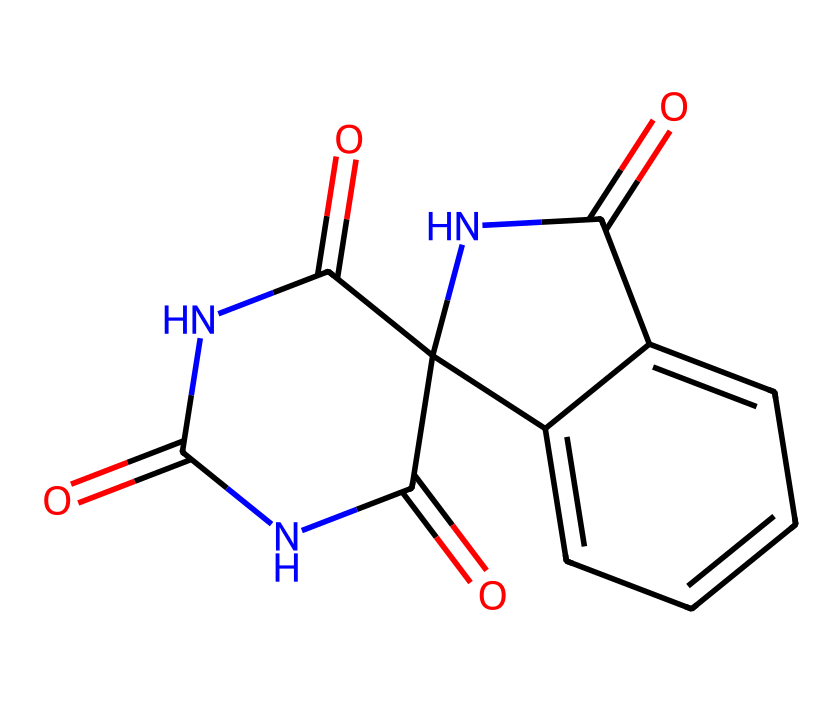How many carbon atoms are present in this compound? The SMILES representation shows a total of 15 carbon (C) atoms, identifiable from the molecular structure as indicated by the count of 'C' characters in the formula.
Answer: 15 What functional groups are present in this chemical? The structure contains amide groups (-C(=O)N-) and carbonyl groups (C=O), which are visible from the arrangement of the atoms in the SMILES representation.
Answer: amide, carbonyl How many nitrogen atoms are in the molecule? From the SMILES notation, there are 3 nitrogen (N) atoms present, identified by the occurrences of 'N' in the structure.
Answer: 3 What is the degree of saturation in this compound? The degree of saturation can be inferred by analyzing the number of double bonds and rings; the presence of both suggests a degree of saturation indicating 9.
Answer: 9 What type of reaction might this compound undergo when exposed to UV light? Given that the compound is UV-reactive due to its conjugated structure, it is likely to undergo a photoisomerization reaction when exposed to UV light.
Answer: photoisomerization Is this compound likely to fluoresce? The arrangement of conjugated π-electrons, suggested by the presence of carbonyl and aromatic groups, typically indicates that such a compound could exhibit fluorescence under UV light illumination.
Answer: yes 